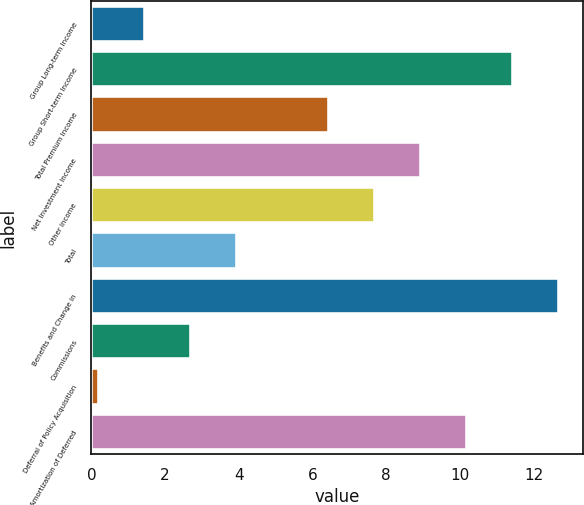Convert chart. <chart><loc_0><loc_0><loc_500><loc_500><bar_chart><fcel>Group Long-term Income<fcel>Group Short-term Income<fcel>Total Premium Income<fcel>Net Investment Income<fcel>Other Income<fcel>Total<fcel>Benefits and Change in<fcel>Commissions<fcel>Deferral of Policy Acquisition<fcel>Amortization of Deferred<nl><fcel>1.45<fcel>11.45<fcel>6.45<fcel>8.95<fcel>7.7<fcel>3.95<fcel>12.7<fcel>2.7<fcel>0.2<fcel>10.2<nl></chart> 